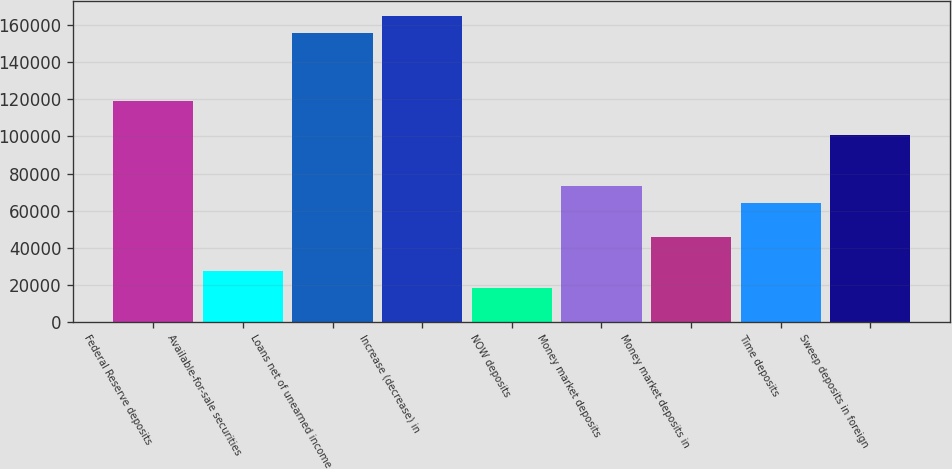Convert chart to OTSL. <chart><loc_0><loc_0><loc_500><loc_500><bar_chart><fcel>Federal Reserve deposits<fcel>Available-for-sale securities<fcel>Loans net of unearned income<fcel>Increase (decrease) in<fcel>NOW deposits<fcel>Money market deposits<fcel>Money market deposits in<fcel>Time deposits<fcel>Sweep deposits in foreign<nl><fcel>119021<fcel>27467.2<fcel>155643<fcel>164798<fcel>18311.8<fcel>73244.2<fcel>45778<fcel>64088.8<fcel>100710<nl></chart> 